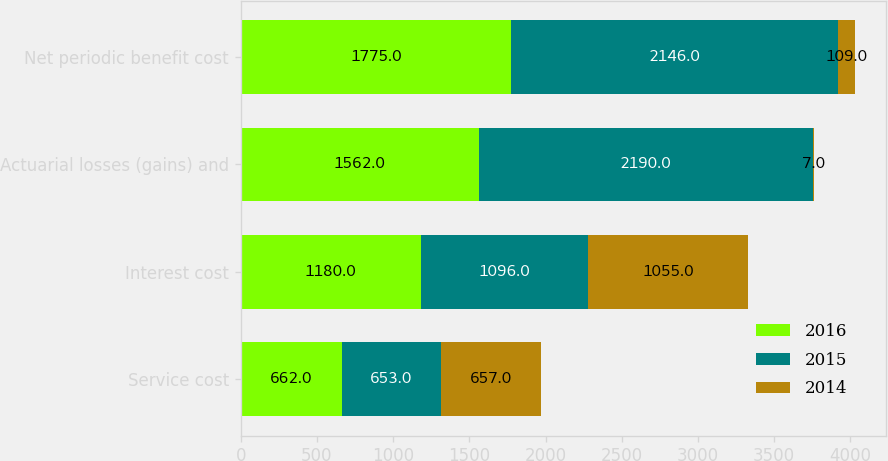Convert chart to OTSL. <chart><loc_0><loc_0><loc_500><loc_500><stacked_bar_chart><ecel><fcel>Service cost<fcel>Interest cost<fcel>Actuarial losses (gains) and<fcel>Net periodic benefit cost<nl><fcel>2016<fcel>662<fcel>1180<fcel>1562<fcel>1775<nl><fcel>2015<fcel>653<fcel>1096<fcel>2190<fcel>2146<nl><fcel>2014<fcel>657<fcel>1055<fcel>7<fcel>109<nl></chart> 